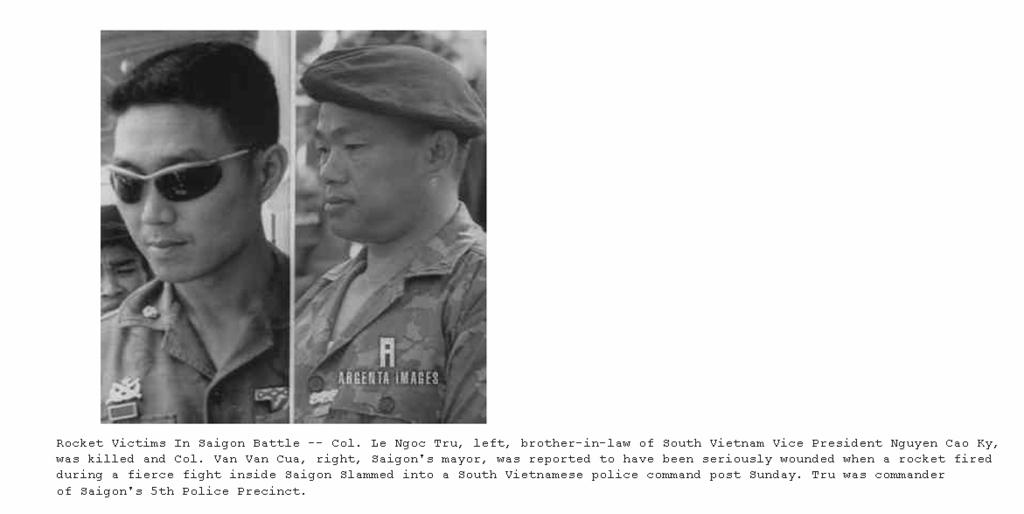What is the color scheme of the image? The image is black and white. How many people are present in the image? There are two persons in the image. What else can be seen in the image besides the people? There are written words in the image. What happens to the edge of the paper when the person in the image bursts into laughter? There is no indication in the image that a person is bursting into laughter, nor is there any paper with an edge visible. 